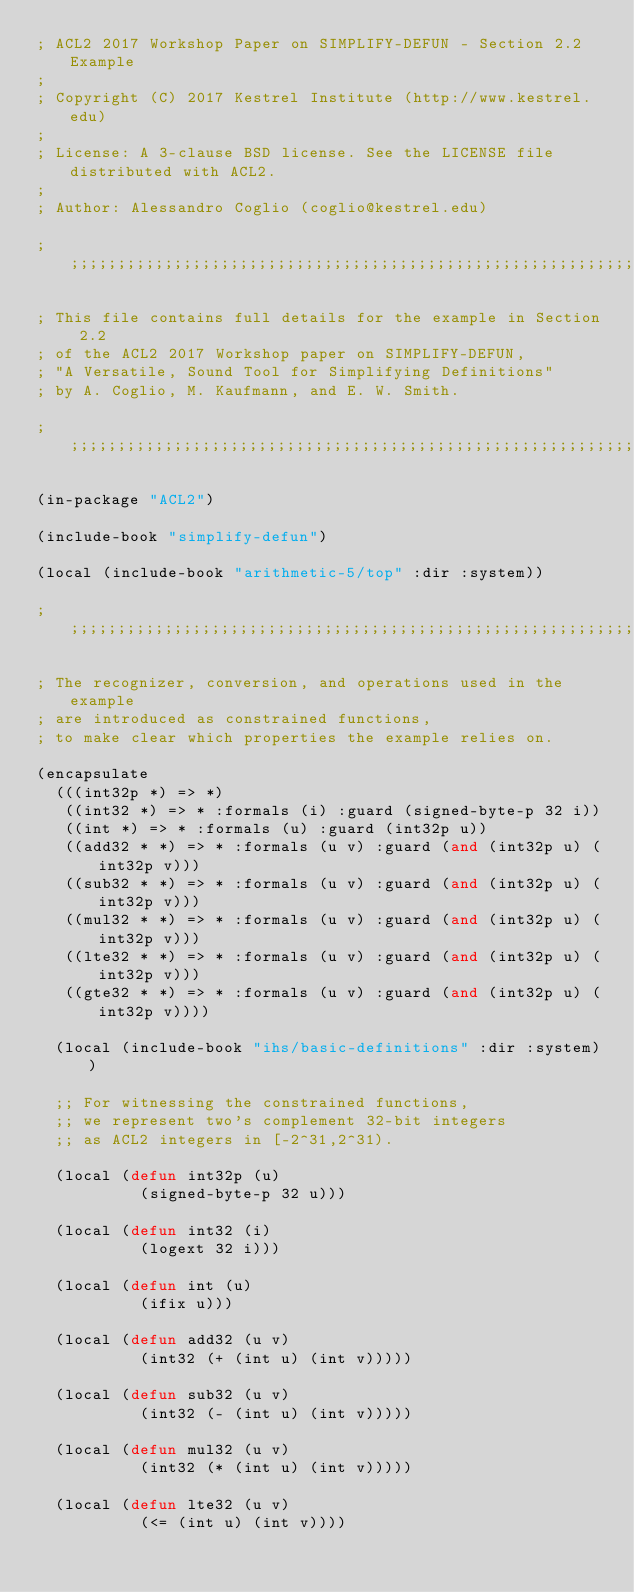<code> <loc_0><loc_0><loc_500><loc_500><_Lisp_>; ACL2 2017 Workshop Paper on SIMPLIFY-DEFUN - Section 2.2 Example
;
; Copyright (C) 2017 Kestrel Institute (http://www.kestrel.edu)
;
; License: A 3-clause BSD license. See the LICENSE file distributed with ACL2.
;
; Author: Alessandro Coglio (coglio@kestrel.edu)

;;;;;;;;;;;;;;;;;;;;;;;;;;;;;;;;;;;;;;;;;;;;;;;;;;;;;;;;;;;;;;;;;;;;;;;;;;;;;;;;

; This file contains full details for the example in Section 2.2
; of the ACL2 2017 Workshop paper on SIMPLIFY-DEFUN,
; "A Versatile, Sound Tool for Simplifying Definitions"
; by A. Coglio, M. Kaufmann, and E. W. Smith.

;;;;;;;;;;;;;;;;;;;;;;;;;;;;;;;;;;;;;;;;;;;;;;;;;;;;;;;;;;;;;;;;;;;;;;;;;;;;;;;;

(in-package "ACL2")

(include-book "simplify-defun")

(local (include-book "arithmetic-5/top" :dir :system))

;;;;;;;;;;;;;;;;;;;;;;;;;;;;;;;;;;;;;;;;;;;;;;;;;;;;;;;;;;;;;;;;;;;;;;;;;;;;;;;;

; The recognizer, conversion, and operations used in the example
; are introduced as constrained functions,
; to make clear which properties the example relies on.

(encapsulate
  (((int32p *) => *)
   ((int32 *) => * :formals (i) :guard (signed-byte-p 32 i))
   ((int *) => * :formals (u) :guard (int32p u))
   ((add32 * *) => * :formals (u v) :guard (and (int32p u) (int32p v)))
   ((sub32 * *) => * :formals (u v) :guard (and (int32p u) (int32p v)))
   ((mul32 * *) => * :formals (u v) :guard (and (int32p u) (int32p v)))
   ((lte32 * *) => * :formals (u v) :guard (and (int32p u) (int32p v)))
   ((gte32 * *) => * :formals (u v) :guard (and (int32p u) (int32p v))))

  (local (include-book "ihs/basic-definitions" :dir :system))

  ;; For witnessing the constrained functions,
  ;; we represent two's complement 32-bit integers
  ;; as ACL2 integers in [-2^31,2^31).

  (local (defun int32p (u)
           (signed-byte-p 32 u)))

  (local (defun int32 (i)
           (logext 32 i)))

  (local (defun int (u)
           (ifix u)))

  (local (defun add32 (u v)
           (int32 (+ (int u) (int v)))))

  (local (defun sub32 (u v)
           (int32 (- (int u) (int v)))))

  (local (defun mul32 (u v)
           (int32 (* (int u) (int v)))))

  (local (defun lte32 (u v)
           (<= (int u) (int v))))
</code> 